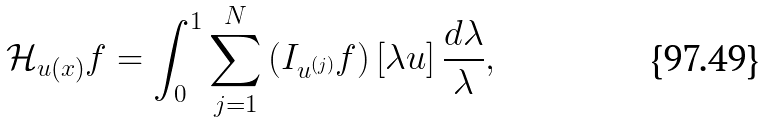Convert formula to latex. <formula><loc_0><loc_0><loc_500><loc_500>\mathcal { H } _ { { u } ( x ) } f = \int _ { 0 } ^ { 1 } \sum _ { j = 1 } ^ { N } \left ( I _ { u ^ { ( j ) } } f \right ) [ \lambda { u } ] \, \frac { d \lambda } { \lambda } ,</formula> 